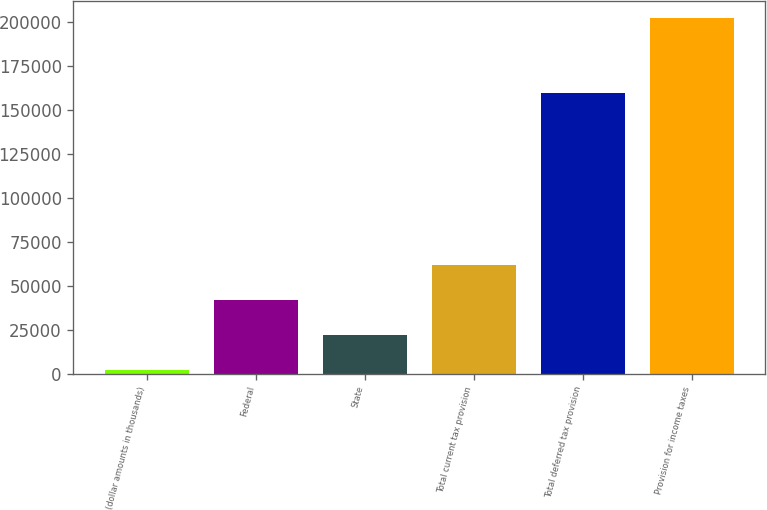Convert chart. <chart><loc_0><loc_0><loc_500><loc_500><bar_chart><fcel>(dollar amounts in thousands)<fcel>Federal<fcel>State<fcel>Total current tax provision<fcel>Total deferred tax provision<fcel>Provision for income taxes<nl><fcel>2012<fcel>42067.8<fcel>22039.9<fcel>62095.7<fcel>159938<fcel>202291<nl></chart> 